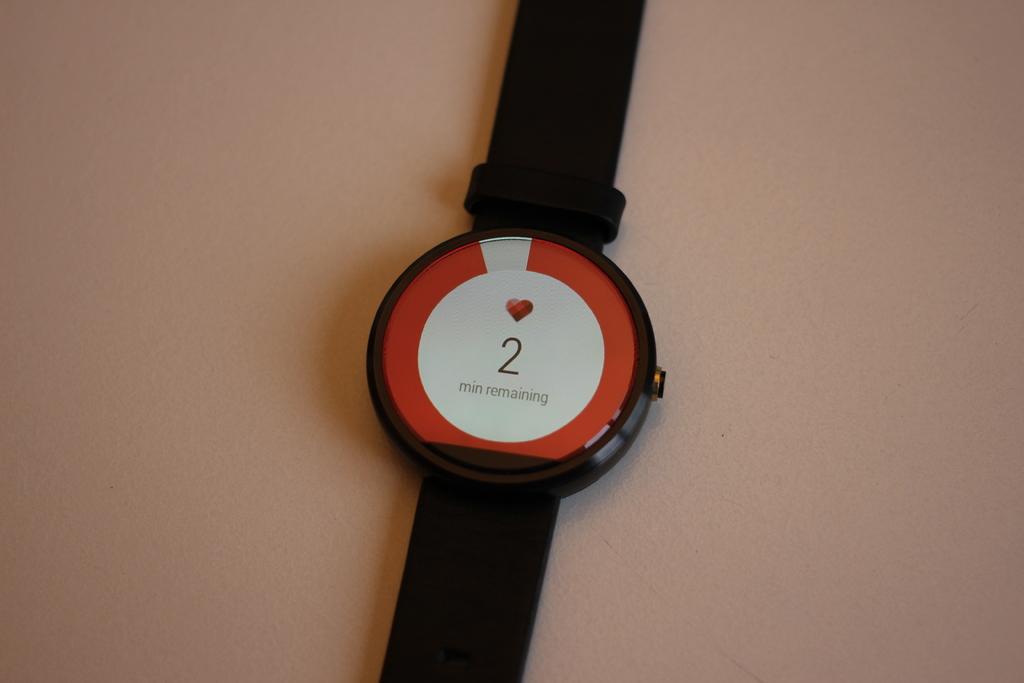What number is shown?
Ensure brevity in your answer.  2. Hat is on the watch?
Provide a succinct answer. 2 min remaining. 